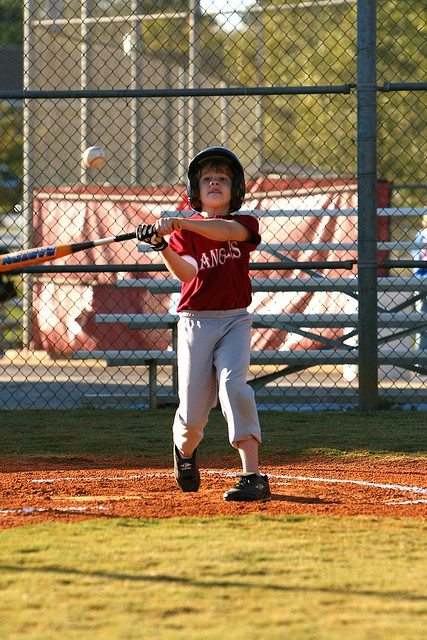Describe the objects in this image and their specific colors. I can see bench in darkgreen, black, gray, ivory, and maroon tones, people in darkgreen, black, gray, and maroon tones, baseball bat in darkgreen, black, brown, and ivory tones, people in darkgreen, white, blue, darkgray, and gray tones, and sports ball in darkgreen, darkgray, gray, ivory, and brown tones in this image. 